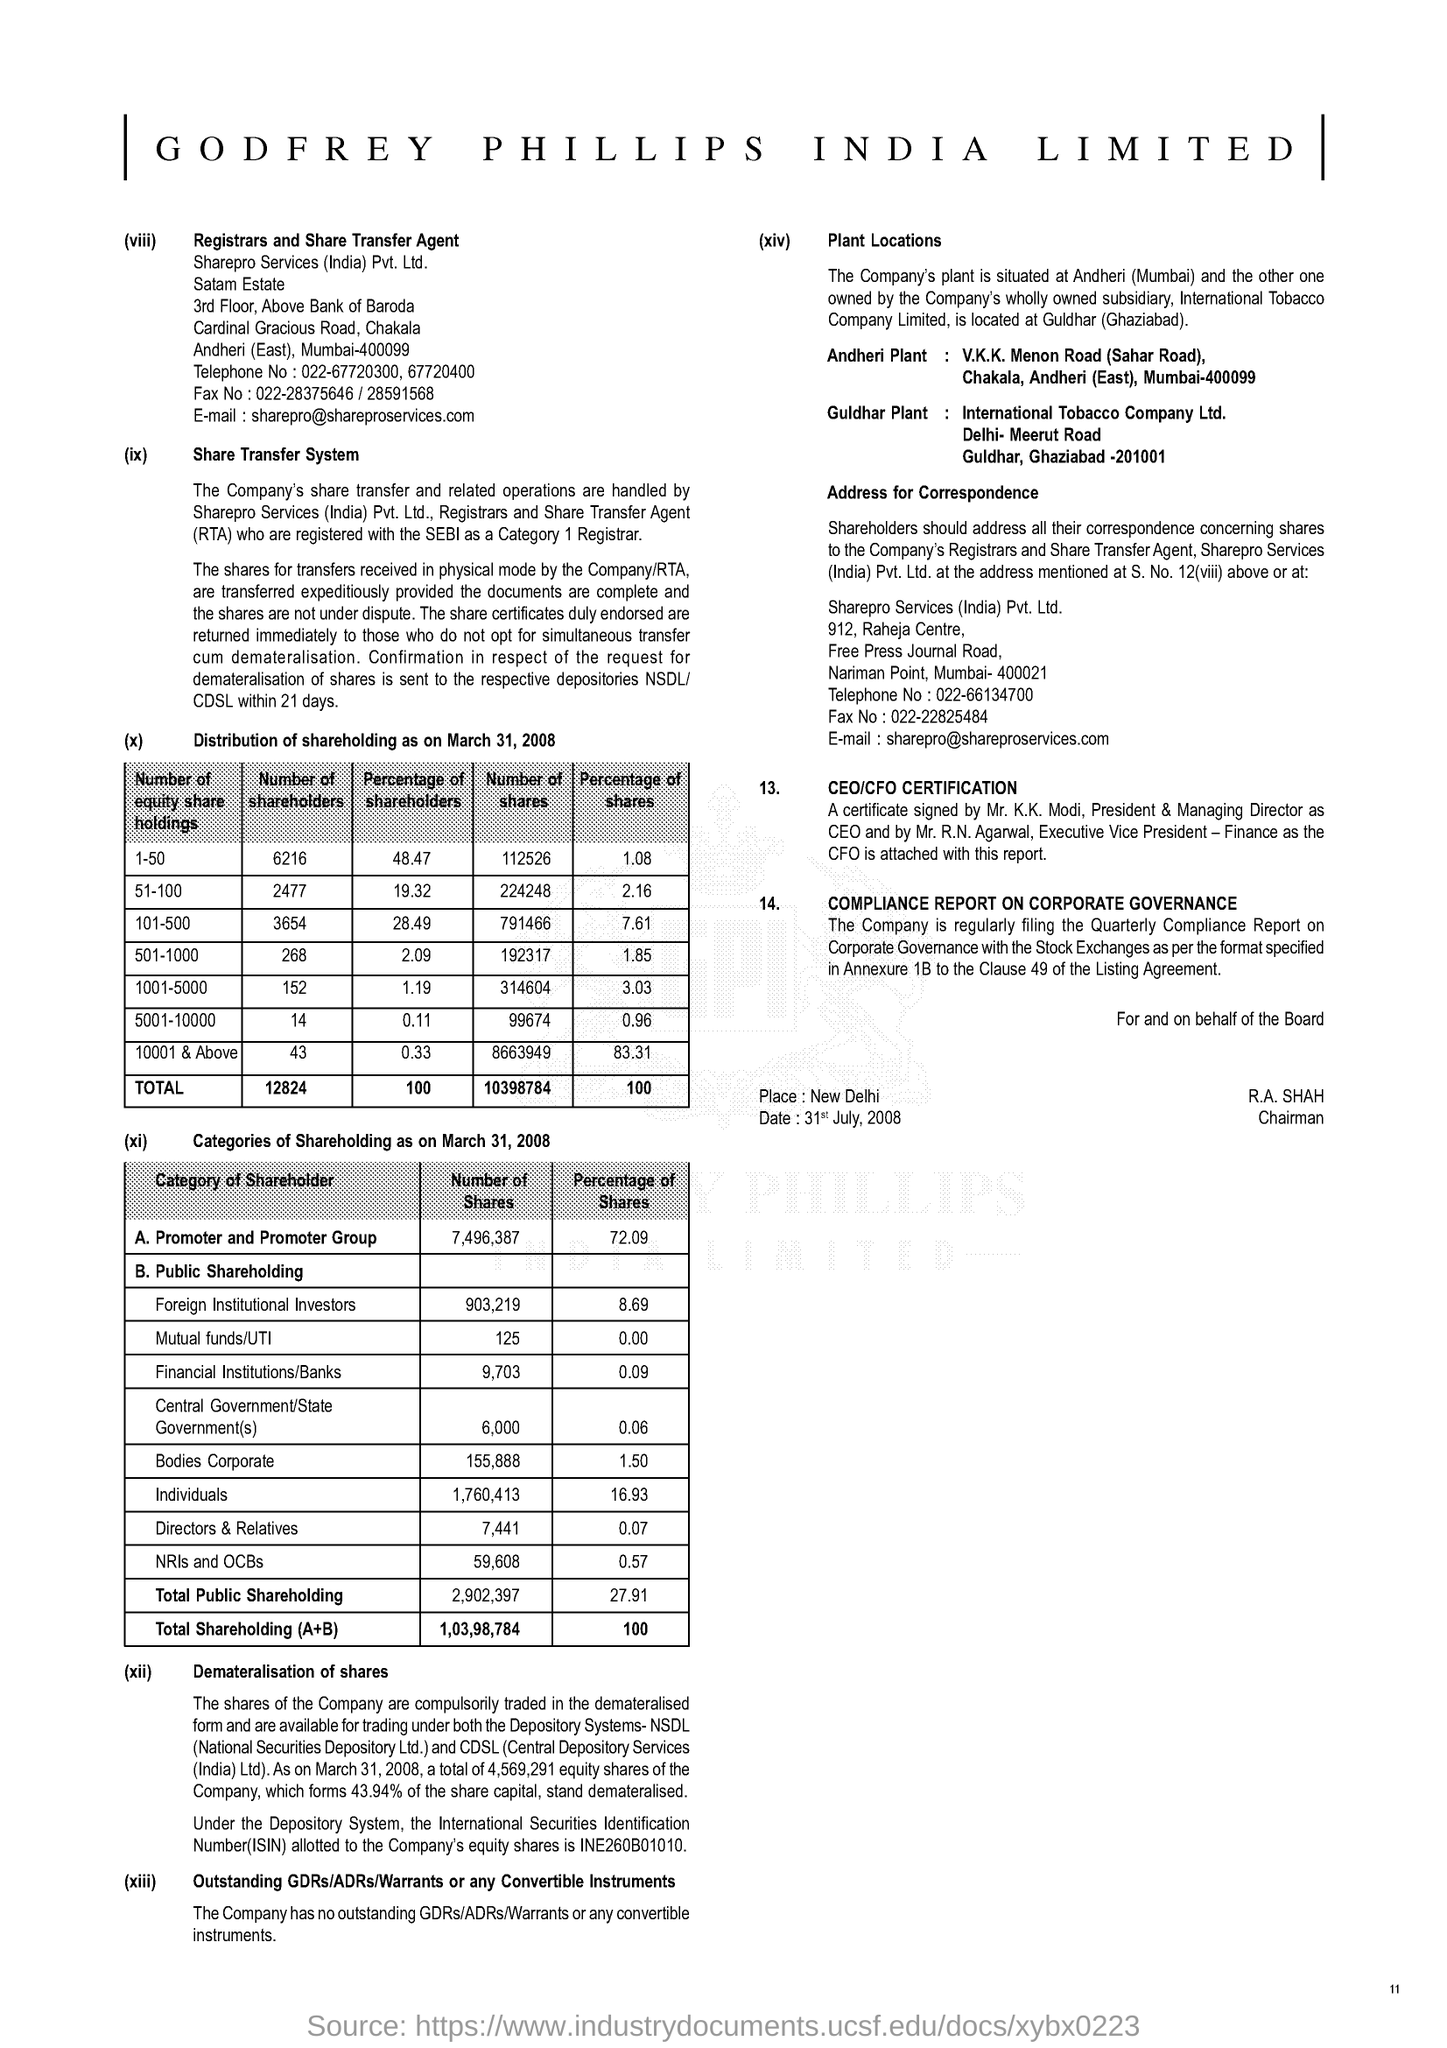Give some essential details in this illustration. International Securities Identification Number (ISIN) is a standardized code used to identify and uniquely identify securities, such as stocks or bonds, traded on various stock exchanges around the world. Out of all shareholders, those between 51 and 100 hold 19.32% of the company. The full form of NSDL is "National Securities Depository Limited. 